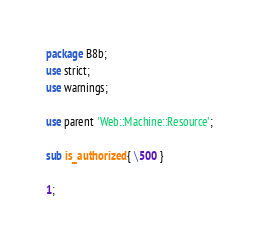<code> <loc_0><loc_0><loc_500><loc_500><_Perl_>package B8b;
use strict;
use warnings;

use parent 'Web::Machine::Resource';

sub is_authorized { \500 }

1;</code> 